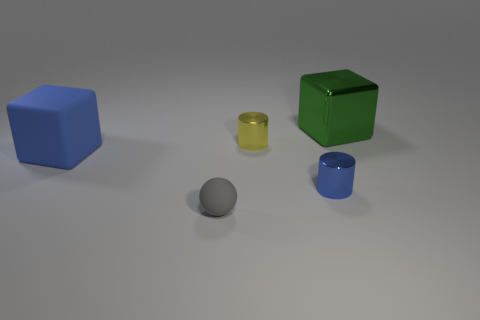What number of big cubes are to the left of the object that is in front of the small cylinder in front of the large blue cube? 1 